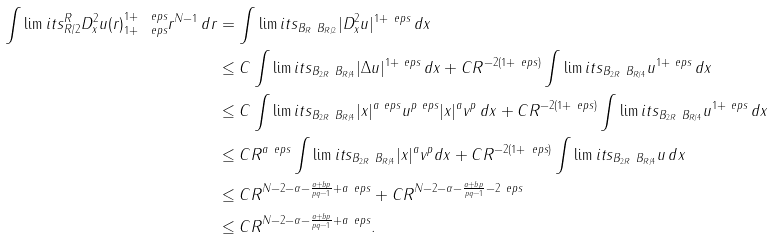Convert formula to latex. <formula><loc_0><loc_0><loc_500><loc_500>\int \lim i t s _ { R / 2 } ^ { R } \| D _ { x } ^ { 2 } u ( r ) \| _ { 1 + \ e p s } ^ { 1 + \ e p s } r ^ { N - 1 } \, d r & = \int \lim i t s _ { B _ { R } \ B _ { R / 2 } } | D _ { x } ^ { 2 } u | ^ { 1 + \ e p s } \, d x \\ & \leq C \int \lim i t s _ { B _ { 2 R } \ B _ { R / 4 } } | \Delta u | ^ { 1 + \ e p s } \, d x + C R ^ { - 2 ( 1 + \ e p s ) } \int \lim i t s _ { B _ { 2 R } \ B _ { R / 4 } } u ^ { 1 + \ e p s } \, d x \\ & \leq C \int \lim i t s _ { B _ { 2 R } \ B _ { R / 4 } } | x | ^ { a \ e p s } u ^ { p \ e p s } | x | ^ { a } v ^ { p } \, d x + C R ^ { - 2 ( 1 + \ e p s ) } \int \lim i t s _ { B _ { 2 R } \ B _ { R / 4 } } u ^ { 1 + \ e p s } \, d x \\ & \leq C R ^ { a \ e p s } \int \lim i t s _ { B _ { 2 R } \ B _ { R / 4 } } | x | ^ { a } v ^ { p } d x + C R ^ { - 2 ( 1 + \ e p s ) } \int \lim i t s _ { B _ { 2 R } \ B _ { R / 4 } } u \, d x \\ & \leq C R ^ { N - 2 - \alpha - \frac { a + b p } { p q - 1 } + a \ e p s } + C R ^ { N - 2 - \alpha - \frac { a + b p } { p q - 1 } - 2 \ e p s } \\ & \leq C R ^ { N - 2 - \alpha - \frac { a + b p } { p q - 1 } + a \ e p s } .</formula> 